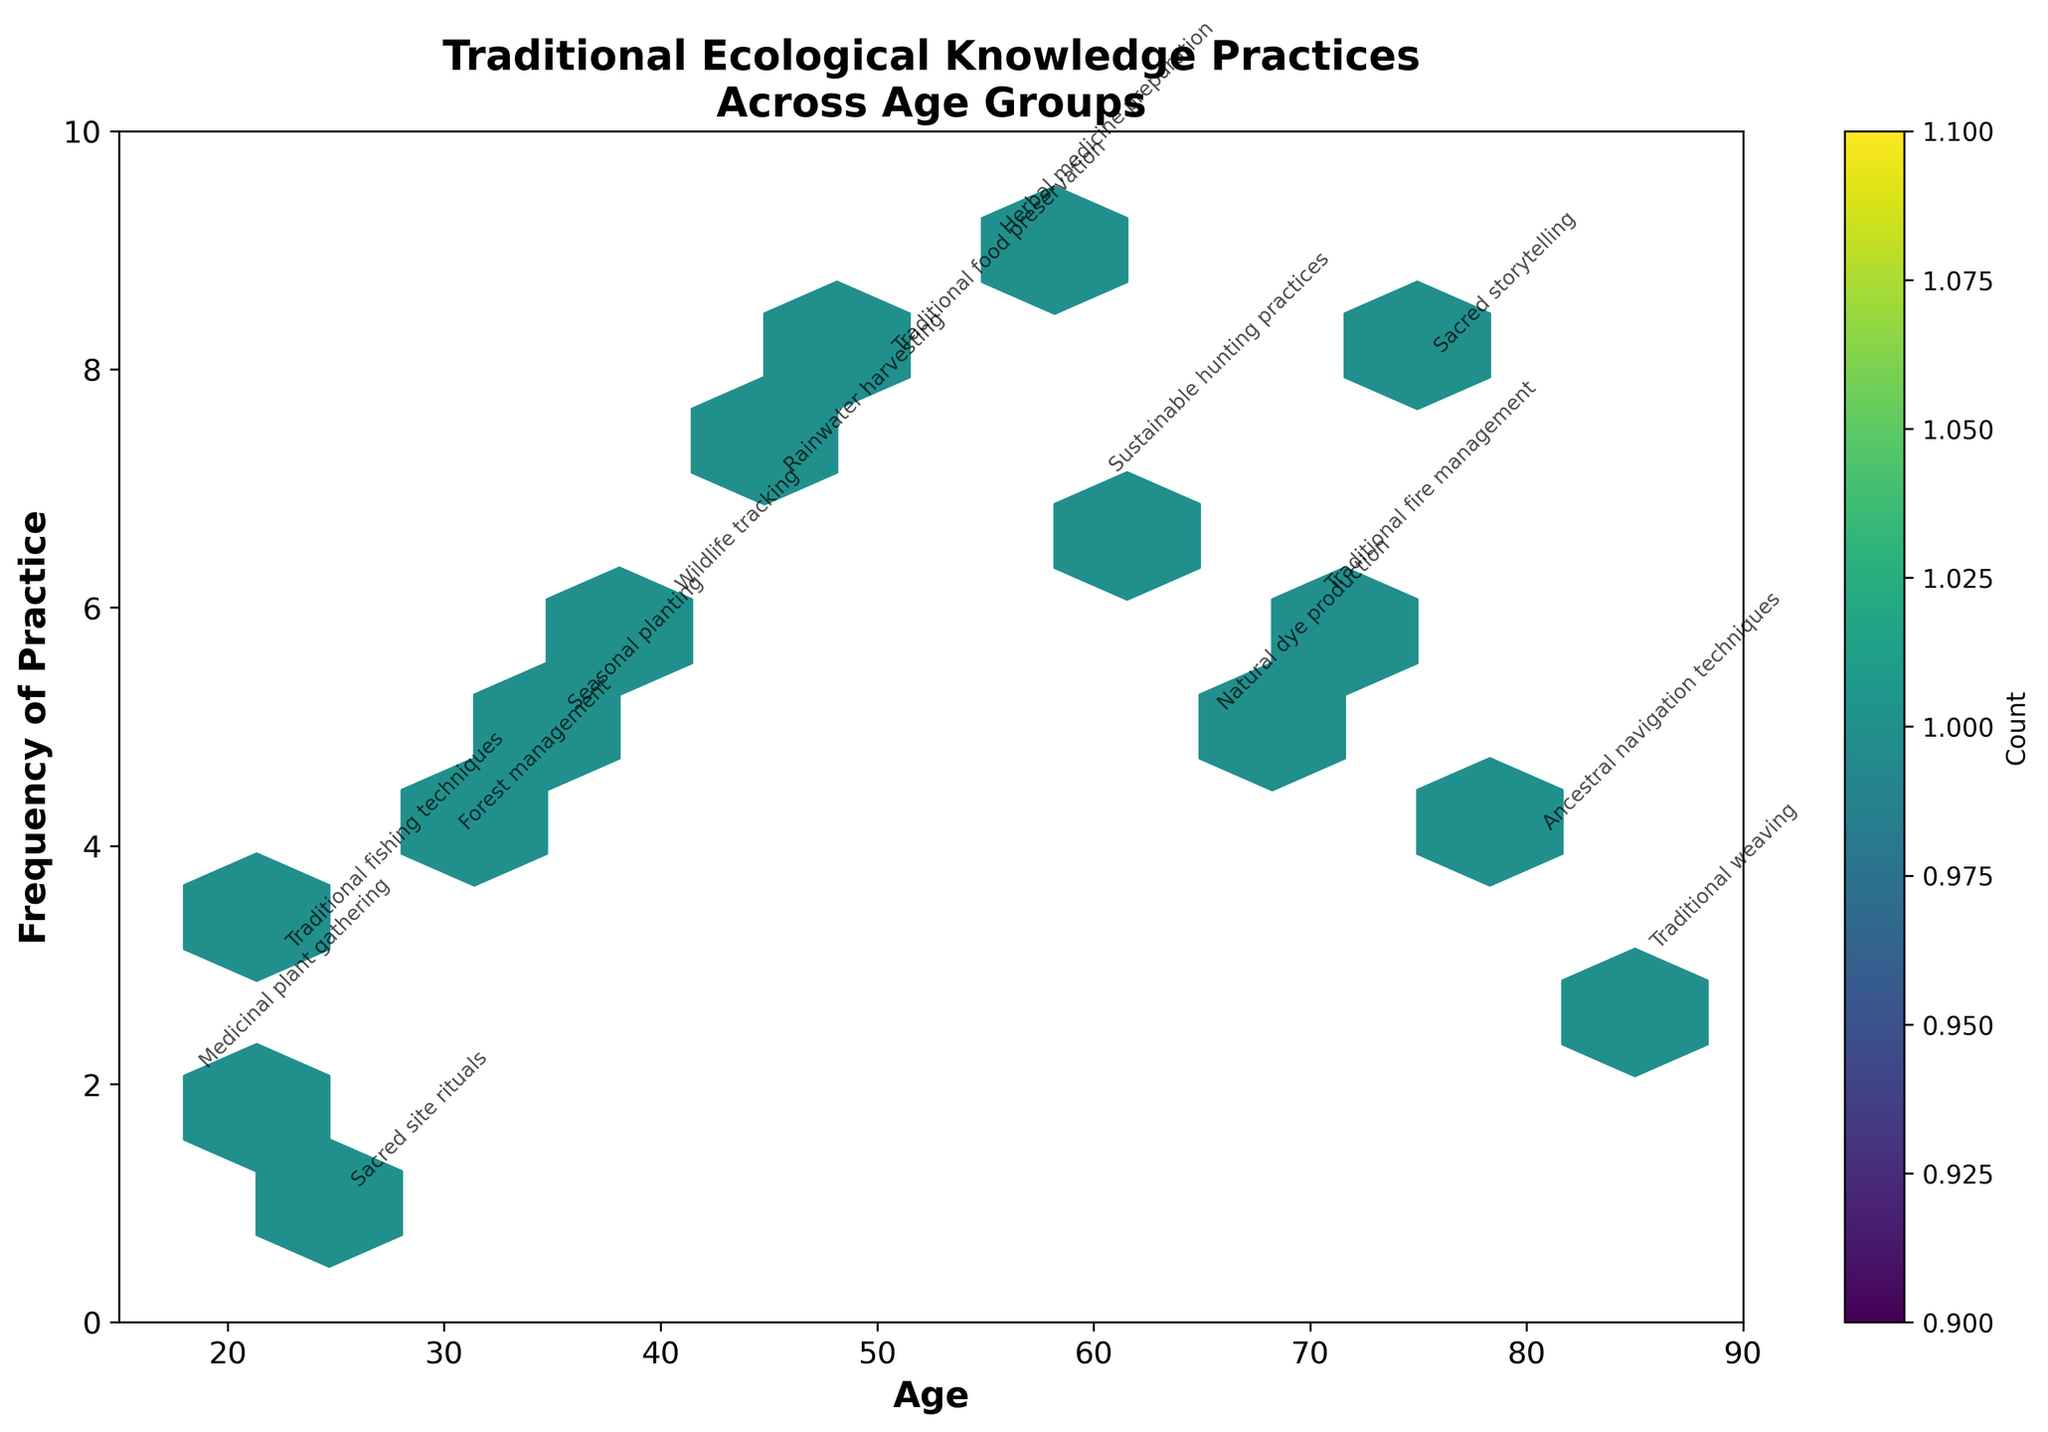What's the title of the figure? The title of a figure is usually presented at the top and indicates the main focus of the plot. Here, it states, "Traditional Ecological Knowledge Practices Across Age Groups".
Answer: Traditional Ecological Knowledge Practices Across Age Groups What is the frequency range shown on the y-axis? The y-axis represents the frequency of practice, with tick marks and labels showing the range. In this case, it goes from 0 to 10.
Answer: 0 to 10 Which age group has the highest frequency of traditional ecological knowledge practice? Observing the data points on the hexbin plot and their annotations, the highest frequency noted is 9 for the age group 55 (Herbal medicine preparation).
Answer: 55 How many different practices are depicted in the figure? Each data point annotation represents a unique traditional ecological practice. Counting the distinct practices yields 15.
Answer: 15 What's the actual count shown by the color bar for the majority of the hexagons? The color bar indicates the count of data points within each hexagon. Most hexagons are shaded in the lighter colors, which correspond to the count of 1.
Answer: 1 Which two age groups have the same frequency of 6 practices, and what are the practices? Observing the hexbin plot, the age groups with a frequency of 6 are 40 (Wildlife tracking) and 70 (Traditional fire management).
Answer: 40: Wildlife tracking, 70: Traditional fire management What average age is associated with a frequency of practice of 4? Identifying the data points with a frequency of 4, annotate the age groups: 30 (Forest management) and 80 (Ancestral navigation techniques). The average of these ages is (30 + 80) / 2 = 55.
Answer: 55 Which age group practices Sacred storytelling, and how frequently? Looking at the annotations, the Sacred storytelling practice is noted at age 75 with a frequency of 8.
Answer: 75, 8 Compare the frequencies of Seasonal planting and Rainwater harvesting. Which is more frequent and by how much? Looking at the annotations, Seasonal planting (35) has a frequency of 5, and Rainwater harvesting (45) has a frequency of 7. The difference in frequencies is 7 - 5 = 2.
Answer: Rainwater harvesting by 2 What is the median frequency value of the data points shown? Listing the frequencies in ascending order: 1, 2, 3, 3, 4, 4, 5, 5, 6, 6, 7, 7, 8, 8, 9. There are 15 data points, so the median is the 8th value, which is 5.
Answer: 5 